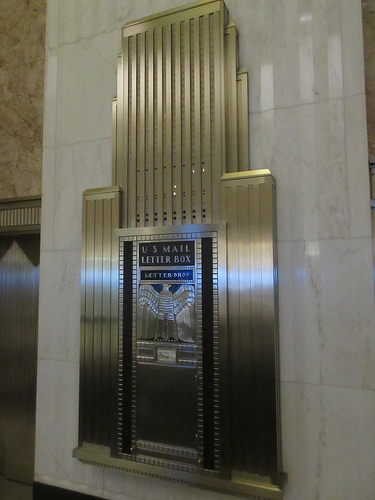<image>
Can you confirm if the mailbox is in the wall? Yes. The mailbox is contained within or inside the wall, showing a containment relationship. Is there a eagle to the left of the label? No. The eagle is not to the left of the label. From this viewpoint, they have a different horizontal relationship. 